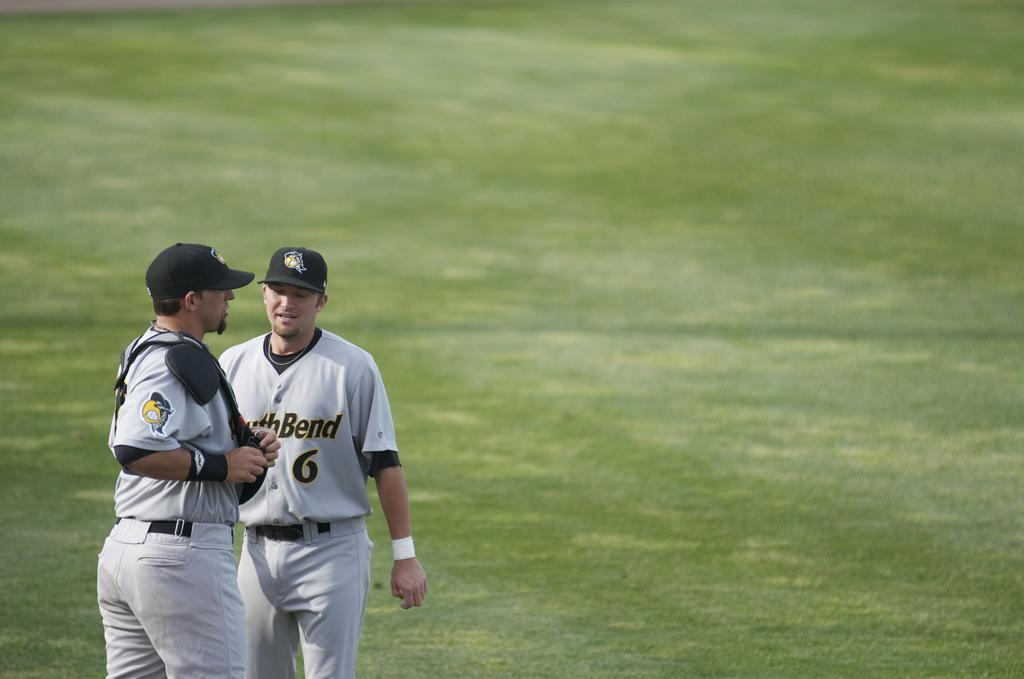Provide a one-sentence caption for the provided image. Two South Bend baseball players, including number 6, gather together in a field to talk. 